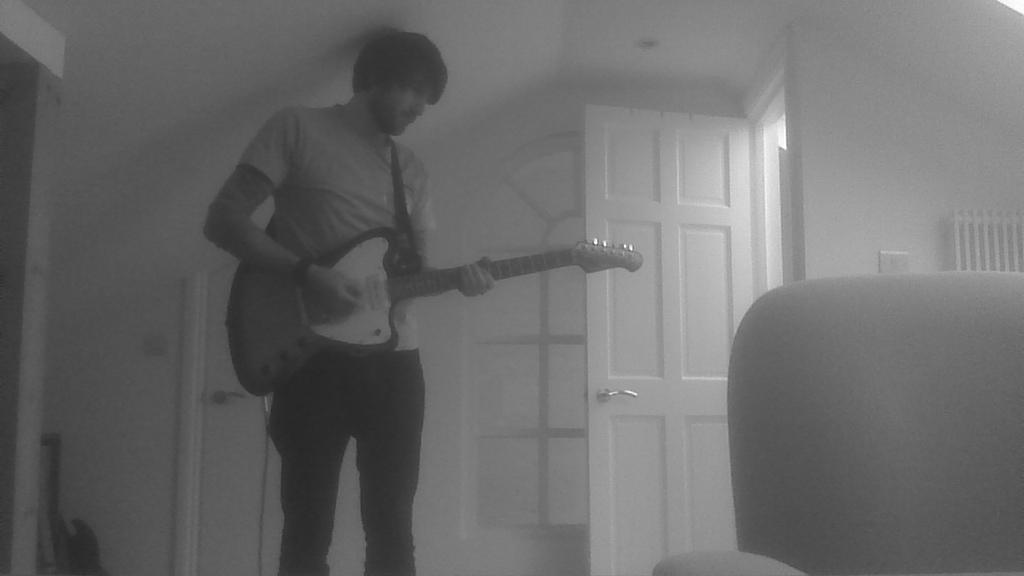Describe this image in one or two sentences. In this picture there is a man standing and playing a guitar. There is a chair. There is a guitar at the corner. There is a door and a door handle. 